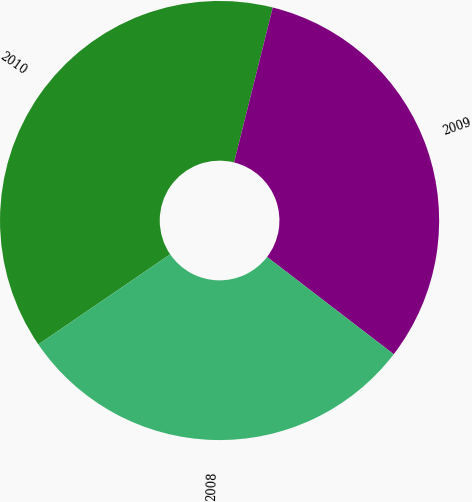<chart> <loc_0><loc_0><loc_500><loc_500><pie_chart><fcel>2010<fcel>2009<fcel>2008<nl><fcel>38.44%<fcel>31.53%<fcel>30.03%<nl></chart> 